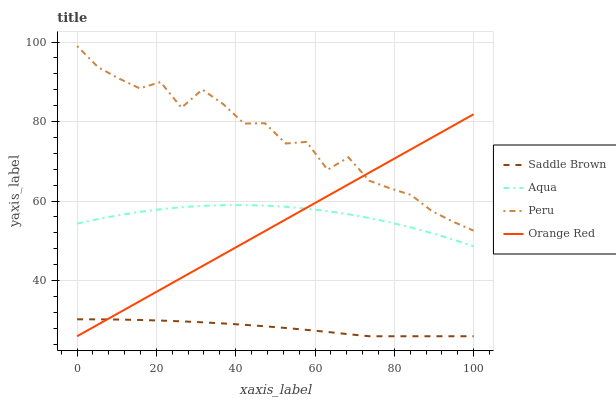Does Saddle Brown have the minimum area under the curve?
Answer yes or no. Yes. Does Peru have the maximum area under the curve?
Answer yes or no. Yes. Does Peru have the minimum area under the curve?
Answer yes or no. No. Does Saddle Brown have the maximum area under the curve?
Answer yes or no. No. Is Orange Red the smoothest?
Answer yes or no. Yes. Is Peru the roughest?
Answer yes or no. Yes. Is Saddle Brown the smoothest?
Answer yes or no. No. Is Saddle Brown the roughest?
Answer yes or no. No. Does Saddle Brown have the lowest value?
Answer yes or no. Yes. Does Peru have the lowest value?
Answer yes or no. No. Does Peru have the highest value?
Answer yes or no. Yes. Does Saddle Brown have the highest value?
Answer yes or no. No. Is Aqua less than Peru?
Answer yes or no. Yes. Is Peru greater than Aqua?
Answer yes or no. Yes. Does Peru intersect Orange Red?
Answer yes or no. Yes. Is Peru less than Orange Red?
Answer yes or no. No. Is Peru greater than Orange Red?
Answer yes or no. No. Does Aqua intersect Peru?
Answer yes or no. No. 